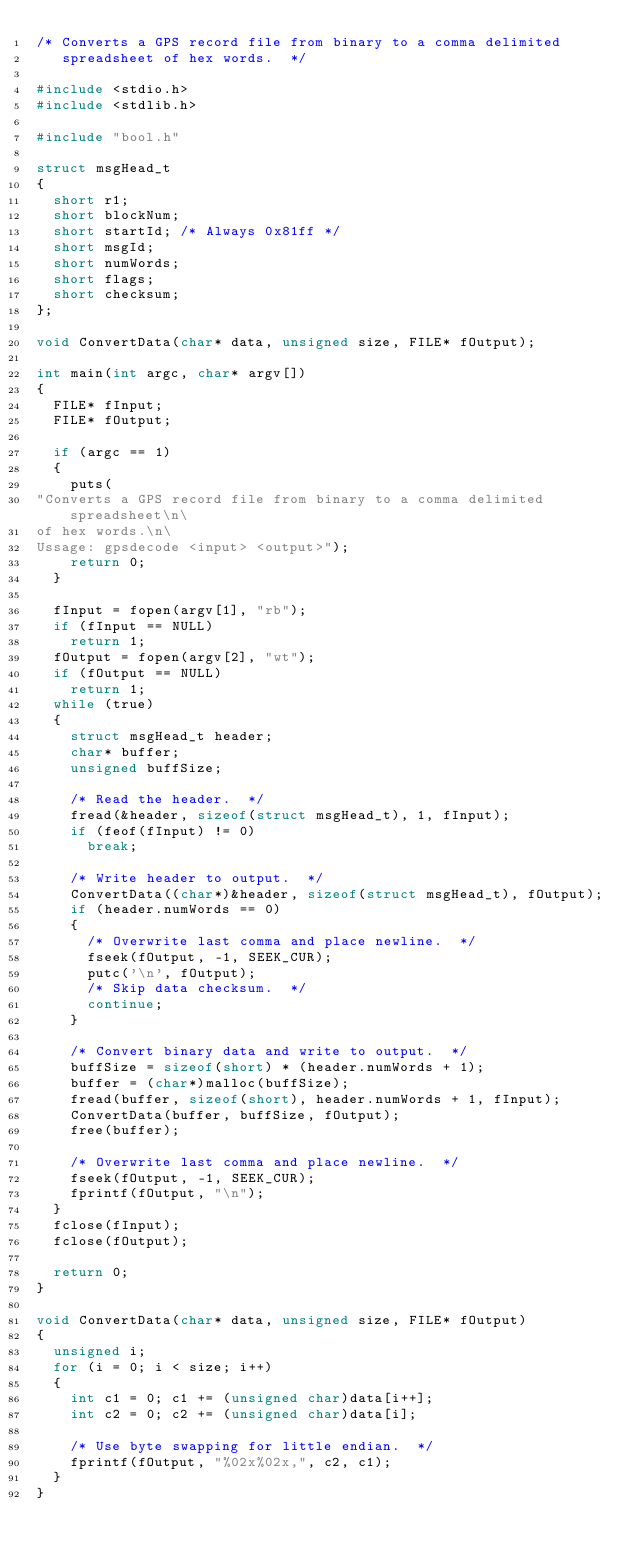<code> <loc_0><loc_0><loc_500><loc_500><_C_>/* Converts a GPS record file from binary to a comma delimited
   spreadsheet of hex words.  */

#include <stdio.h>
#include <stdlib.h>

#include "bool.h"

struct msgHead_t
{
	short r1;
	short blockNum;
	short startId; /* Always 0x81ff */
	short msgId;
	short numWords;
	short flags;
	short checksum;
};

void ConvertData(char* data, unsigned size, FILE* fOutput);

int main(int argc, char* argv[])
{
	FILE* fInput;
	FILE* fOutput;

	if (argc == 1)
	{
		puts(
"Converts a GPS record file from binary to a comma delimited spreadsheet\n\
of hex words.\n\
Ussage: gpsdecode <input> <output>");
		return 0;
	}

	fInput = fopen(argv[1], "rb");
	if (fInput == NULL)
		return 1;
	fOutput = fopen(argv[2], "wt");
	if (fOutput == NULL)
		return 1;
	while (true)
	{
		struct msgHead_t header;
		char* buffer;
		unsigned buffSize;

		/* Read the header.  */
		fread(&header, sizeof(struct msgHead_t), 1, fInput);
		if (feof(fInput) != 0)
			break;

		/* Write header to output.  */
		ConvertData((char*)&header, sizeof(struct msgHead_t), fOutput);
		if (header.numWords == 0)
		{
			/* Overwrite last comma and place newline.  */
			fseek(fOutput, -1, SEEK_CUR);
			putc('\n', fOutput);
			/* Skip data checksum.  */
			continue;
		}

		/* Convert binary data and write to output.  */
		buffSize = sizeof(short) * (header.numWords + 1);
		buffer = (char*)malloc(buffSize);
		fread(buffer, sizeof(short), header.numWords + 1, fInput);
		ConvertData(buffer, buffSize, fOutput);
		free(buffer);

		/* Overwrite last comma and place newline.  */
		fseek(fOutput, -1, SEEK_CUR);
		fprintf(fOutput, "\n");
	}
	fclose(fInput);
	fclose(fOutput);

	return 0;
}

void ConvertData(char* data, unsigned size, FILE* fOutput)
{
	unsigned i;
	for (i = 0; i < size; i++)
	{
		int c1 = 0; c1 += (unsigned char)data[i++];
		int c2 = 0; c2 += (unsigned char)data[i];

		/* Use byte swapping for little endian.  */
		fprintf(fOutput, "%02x%02x,", c2, c1);
	}
}
</code> 